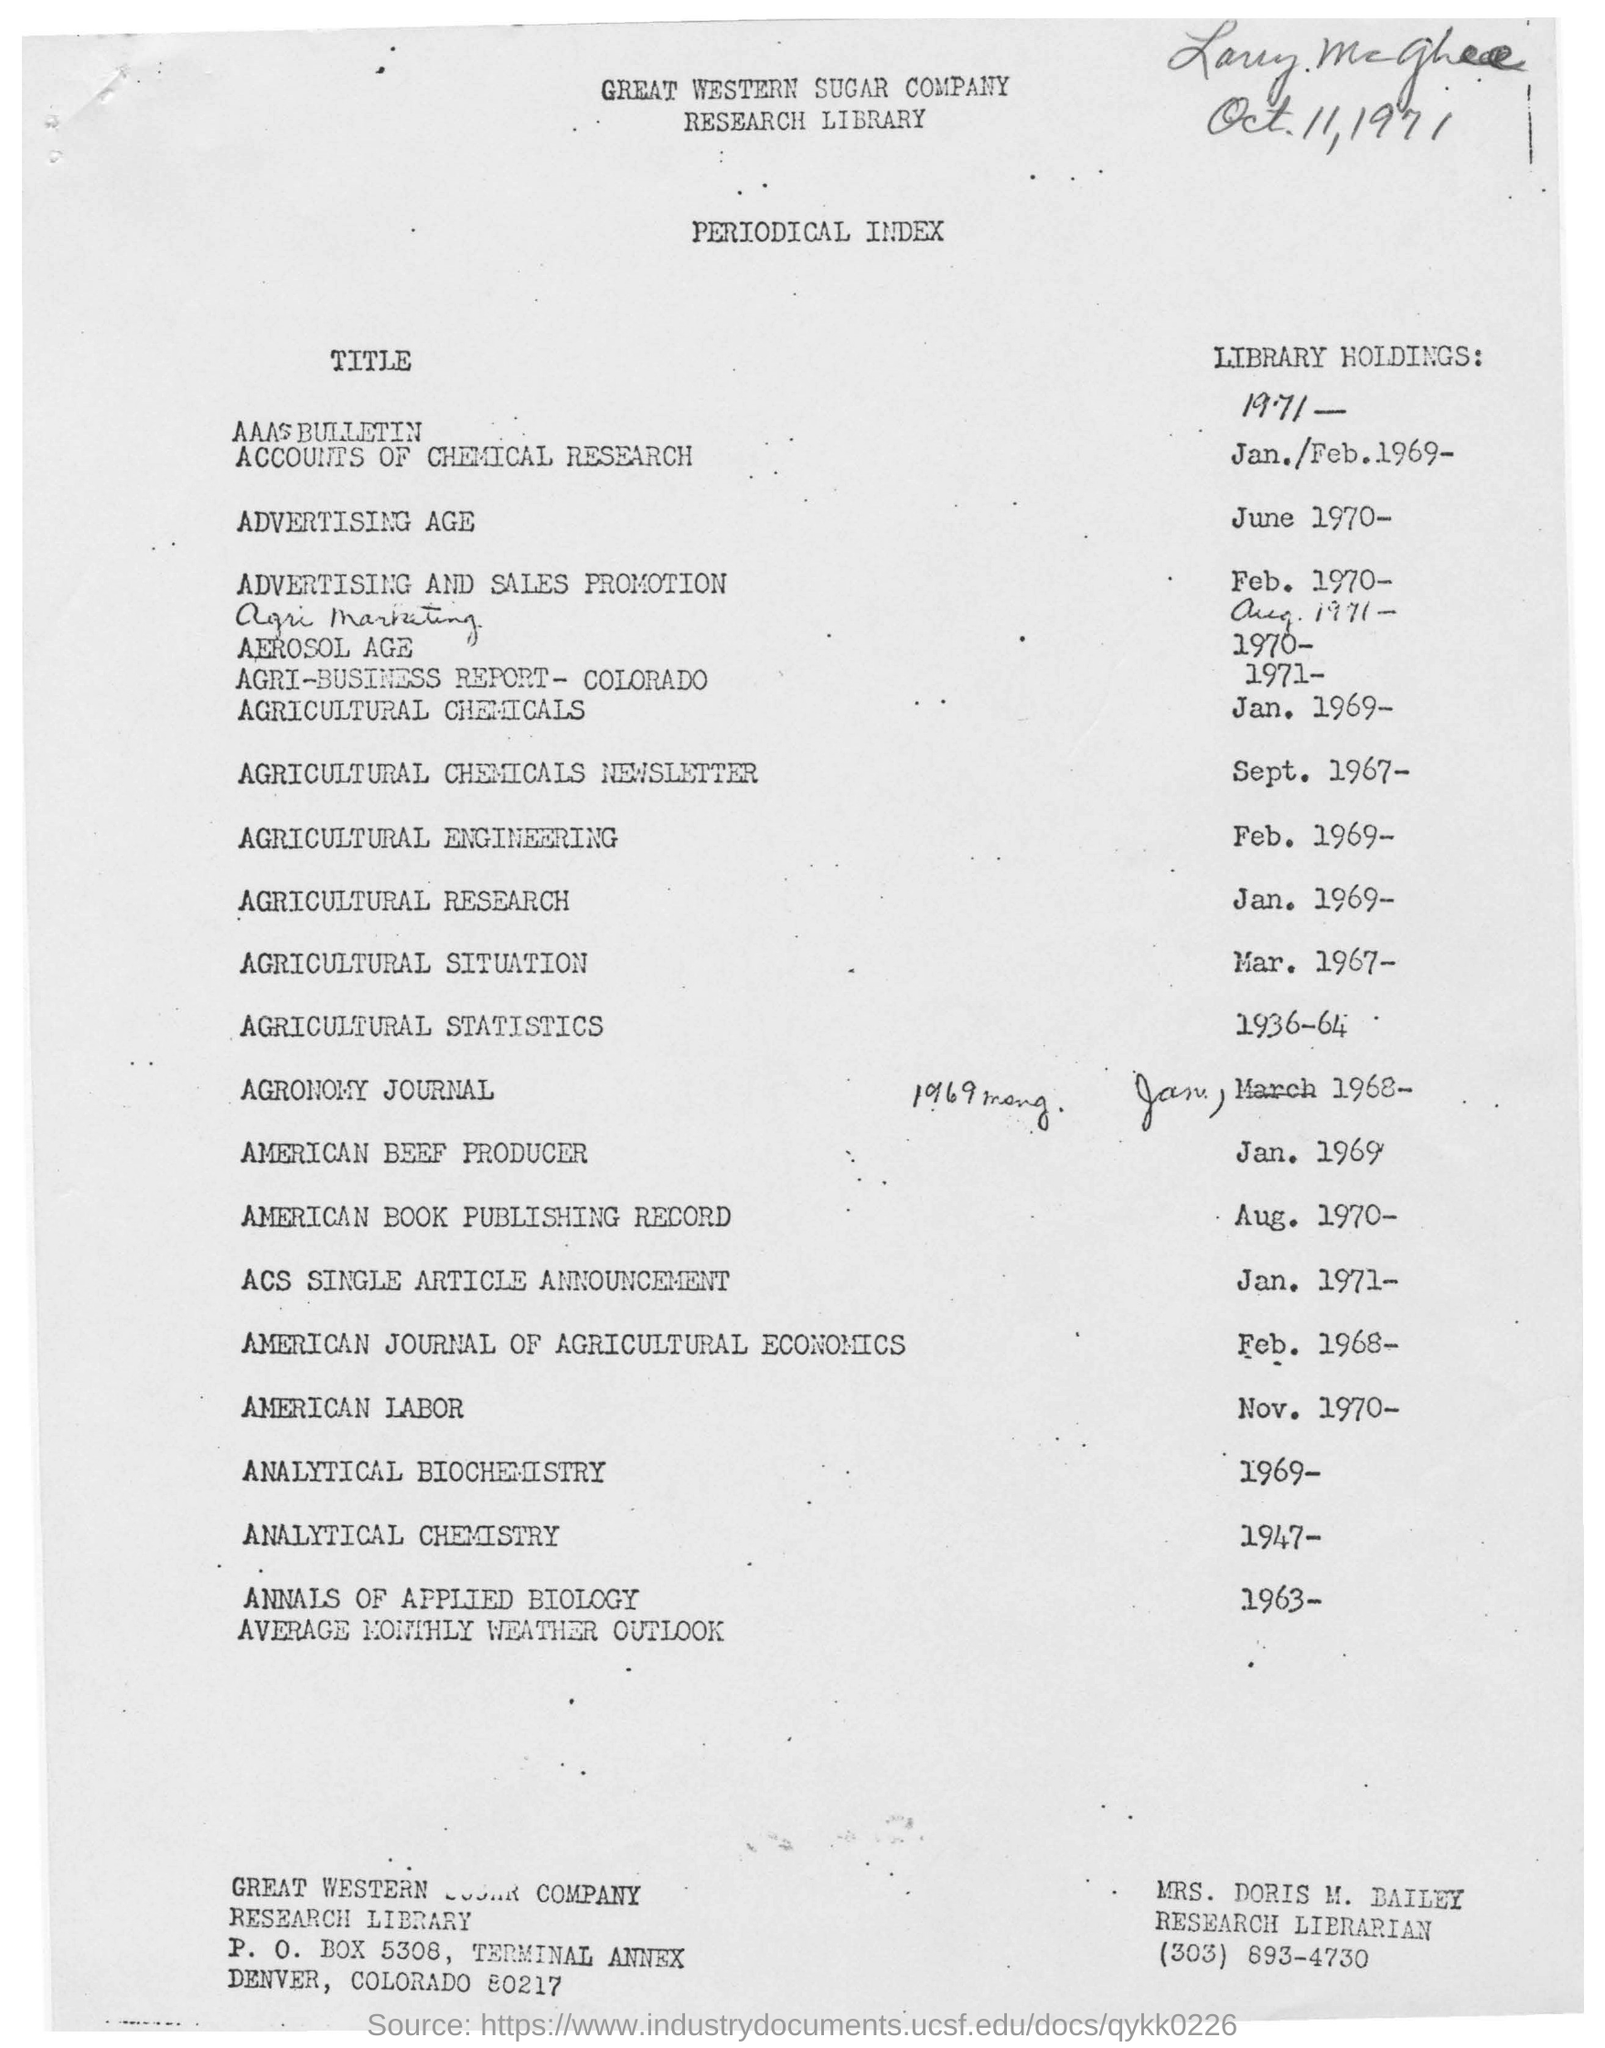What is the name of the company
Give a very brief answer. Great Western Sugar Company. What sort of index it is?
Offer a very short reply. Periodical Index. What is handwritten date in this document?
Make the answer very short. Oct. 11, 1971. What is the P.O box number of Great  Western Sugar Company?
Offer a very short reply. P. O. Box 5308. Whose name is mentioned below the document?
Your response must be concise. Mrs. Doris M. Bailey. 